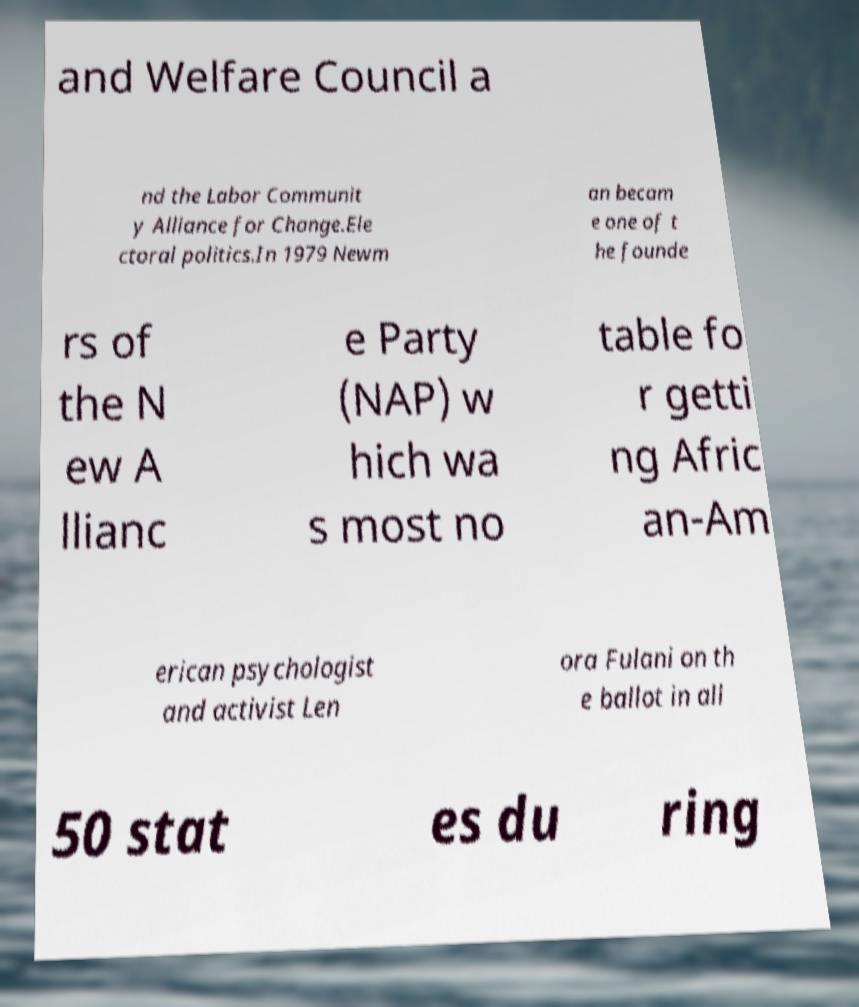Can you accurately transcribe the text from the provided image for me? and Welfare Council a nd the Labor Communit y Alliance for Change.Ele ctoral politics.In 1979 Newm an becam e one of t he founde rs of the N ew A llianc e Party (NAP) w hich wa s most no table fo r getti ng Afric an-Am erican psychologist and activist Len ora Fulani on th e ballot in all 50 stat es du ring 